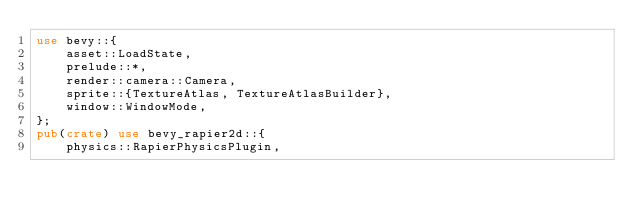Convert code to text. <code><loc_0><loc_0><loc_500><loc_500><_Rust_>use bevy::{
    asset::LoadState,
    prelude::*,
    render::camera::Camera,
    sprite::{TextureAtlas, TextureAtlasBuilder},
    window::WindowMode,
};
pub(crate) use bevy_rapier2d::{
    physics::RapierPhysicsPlugin,</code> 